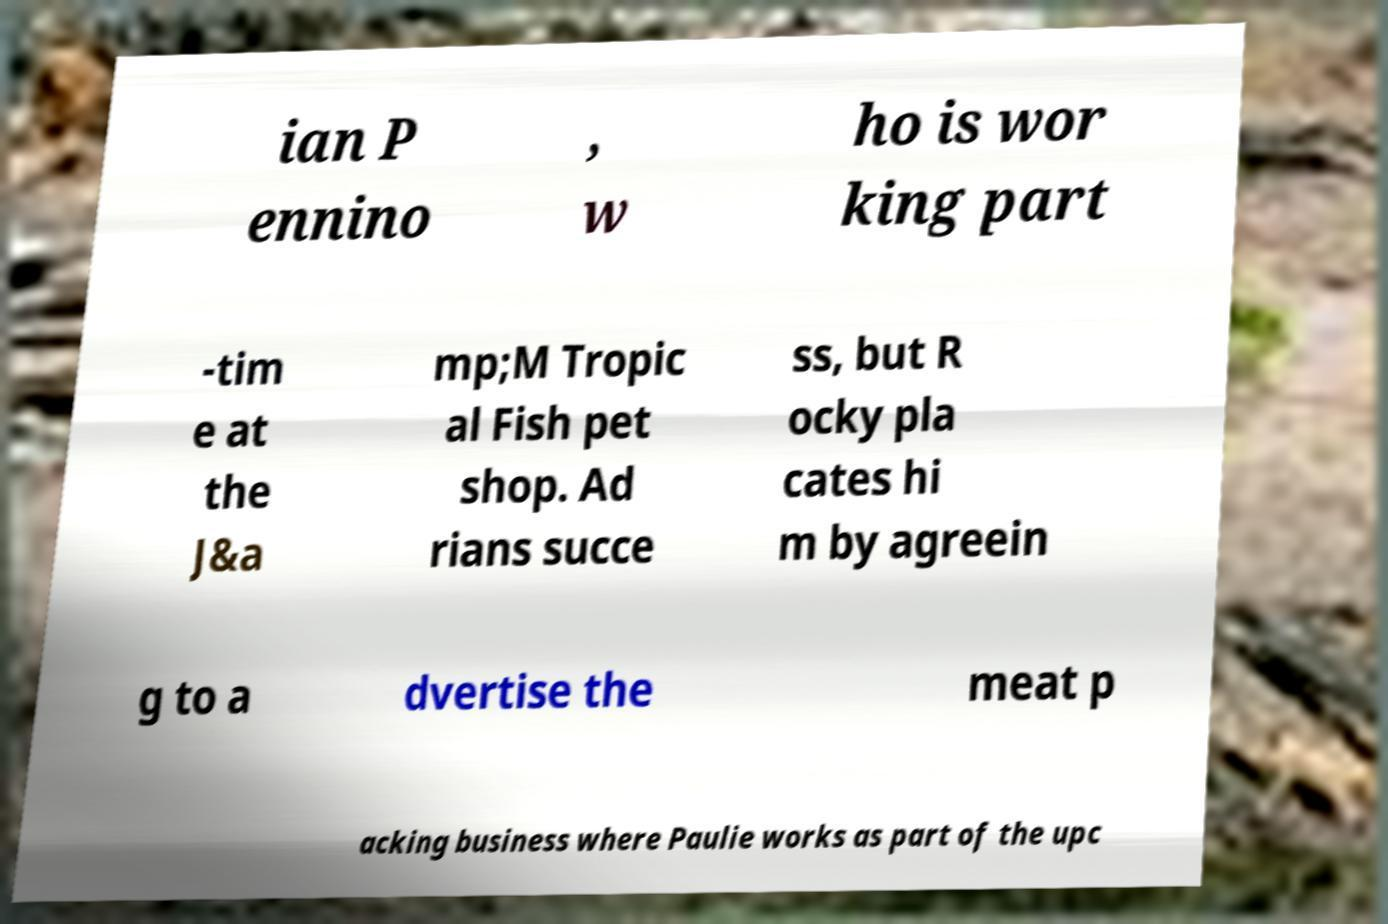Can you read and provide the text displayed in the image?This photo seems to have some interesting text. Can you extract and type it out for me? ian P ennino , w ho is wor king part -tim e at the J&a mp;M Tropic al Fish pet shop. Ad rians succe ss, but R ocky pla cates hi m by agreein g to a dvertise the meat p acking business where Paulie works as part of the upc 